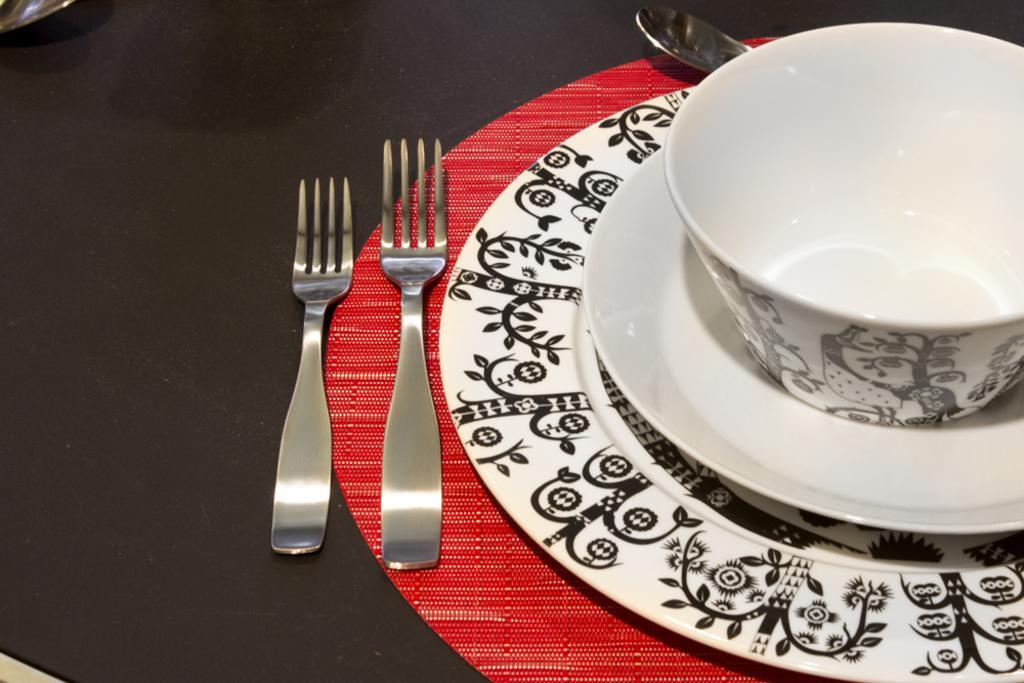Please provide a concise description of this image. In this image we can see a bowl, two plates and a fork on the red mat. We can also see a spoon and another fork on the black surface. 